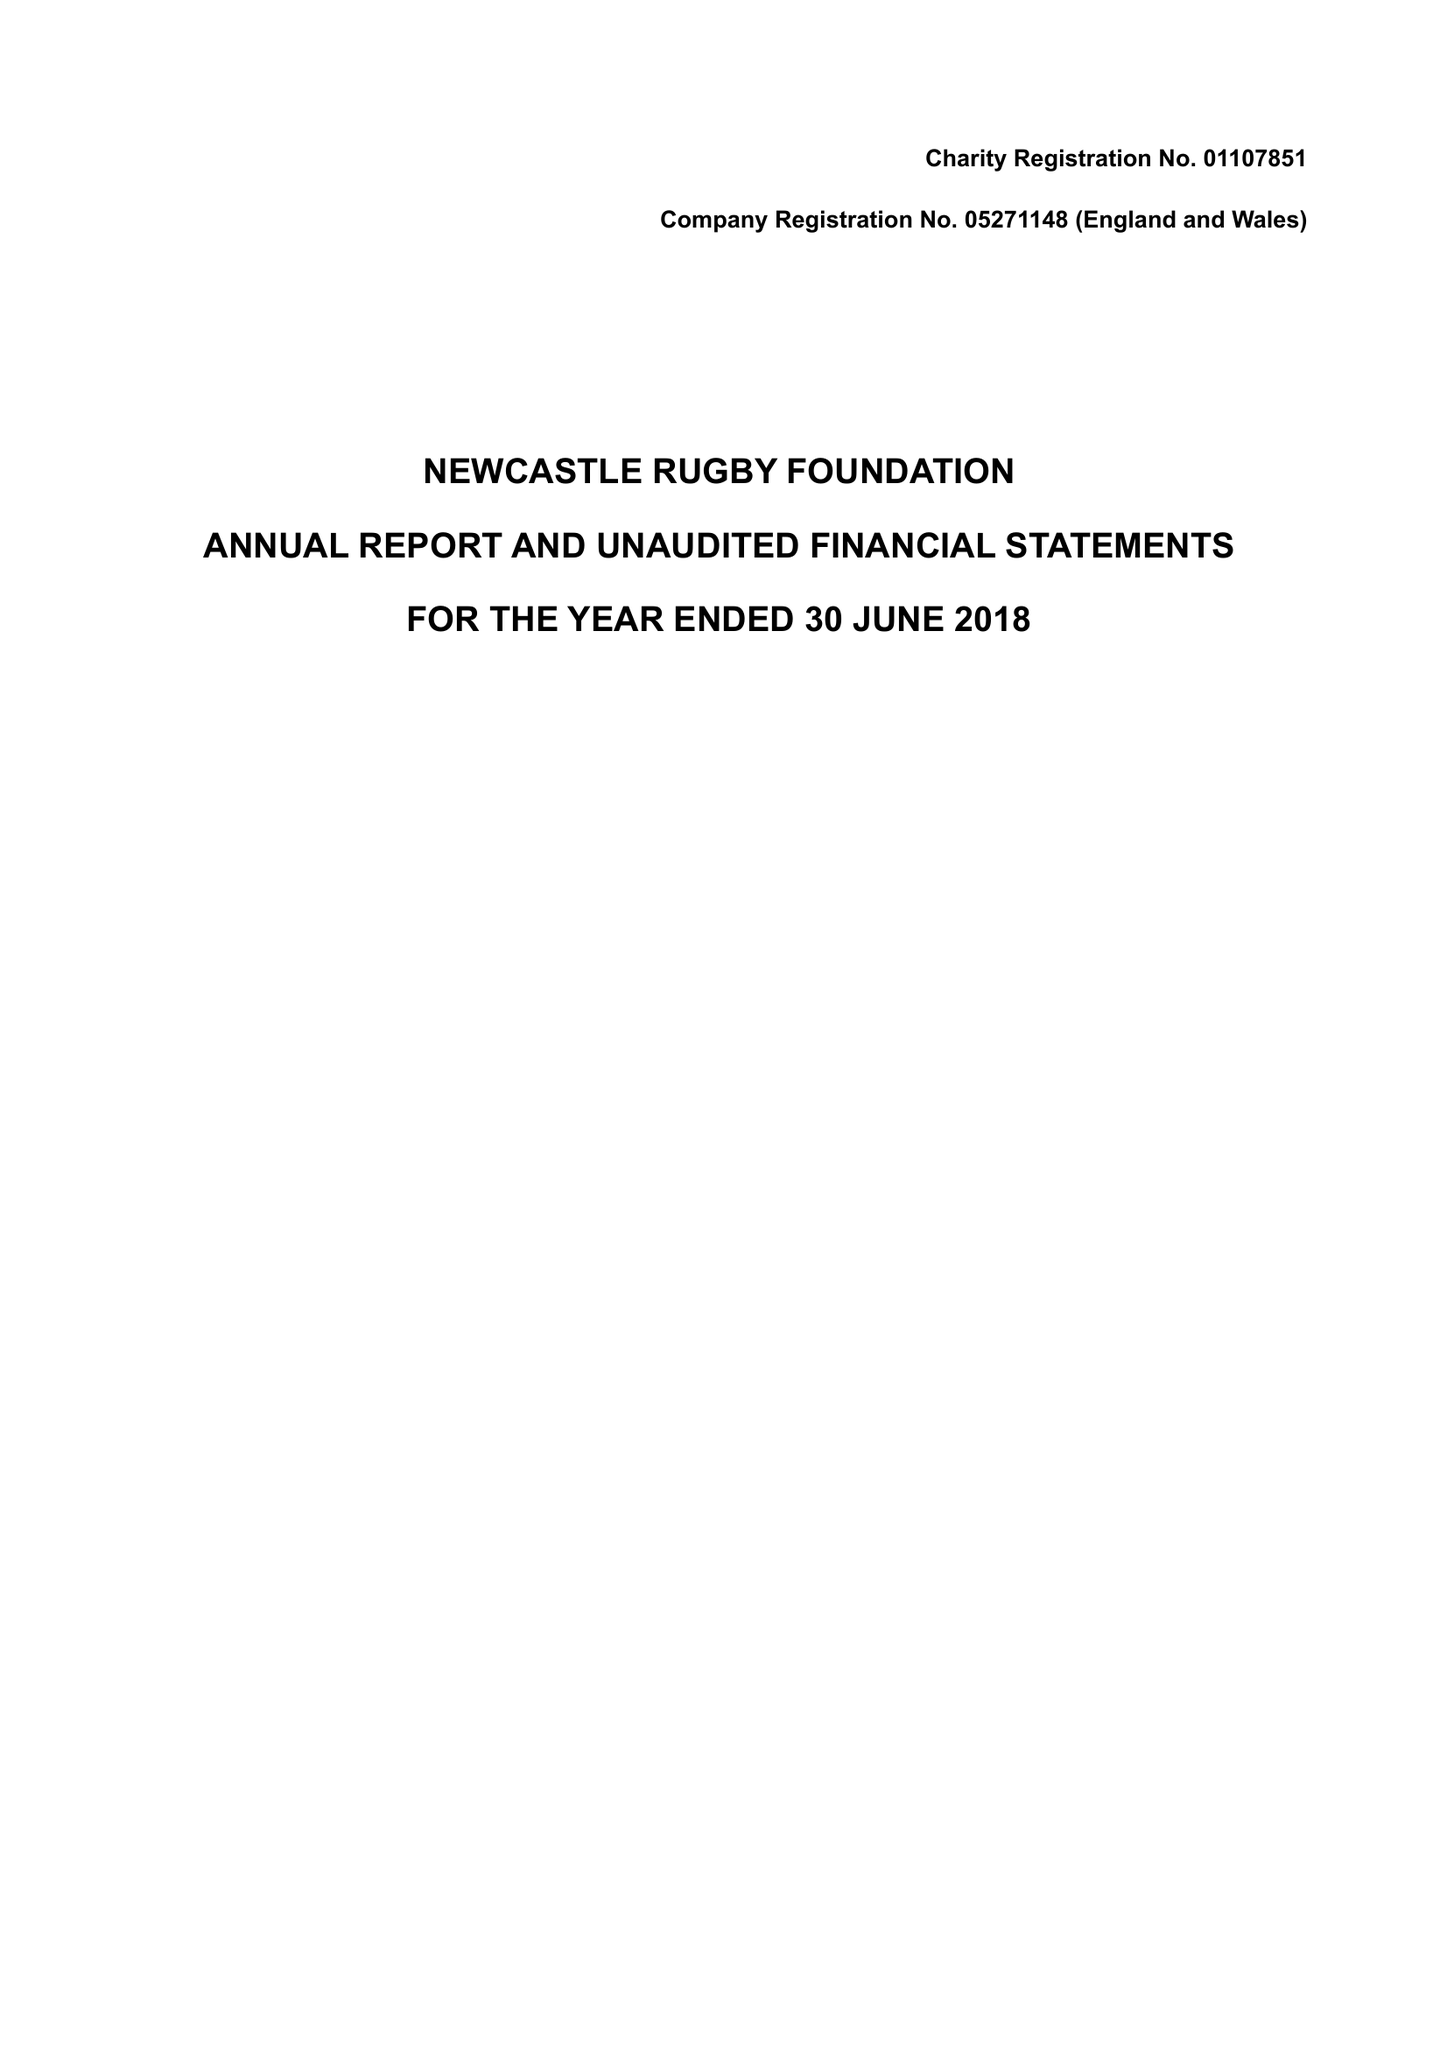What is the value for the report_date?
Answer the question using a single word or phrase. 2018-06-30 